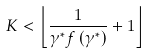Convert formula to latex. <formula><loc_0><loc_0><loc_500><loc_500>K < \left \lfloor \frac { 1 } { \gamma ^ { * } f \left ( \gamma ^ { * } \right ) } + 1 \right \rfloor</formula> 